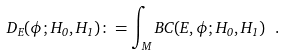Convert formula to latex. <formula><loc_0><loc_0><loc_500><loc_500>D _ { E } ( \phi ; H _ { 0 } , H _ { 1 } ) \colon = \int _ { M } B C ( E , \phi ; H _ { 0 } , H _ { 1 } ) \ .</formula> 